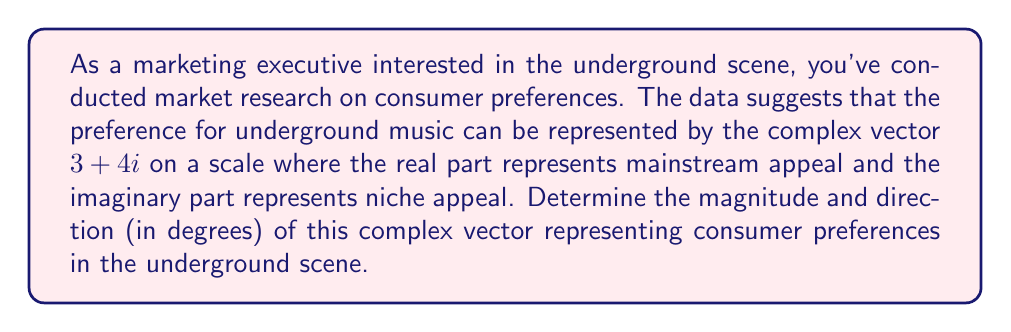Show me your answer to this math problem. To solve this problem, we need to convert the complex vector from rectangular form $(a + bi)$ to polar form $(r \angle \theta)$.

1. Calculate the magnitude (r):
   The magnitude is given by the formula: $r = \sqrt{a^2 + b^2}$
   Where $a = 3$ and $b = 4$
   
   $$r = \sqrt{3^2 + 4^2} = \sqrt{9 + 16} = \sqrt{25} = 5$$

2. Calculate the direction (θ):
   The direction is given by the formula: $\theta = \tan^{-1}(\frac{b}{a})$
   
   $$\theta = \tan^{-1}(\frac{4}{3})$$
   
   Using a calculator or computer:
   $$\theta \approx 0.9272952180 \text{ radians}$$

3. Convert radians to degrees:
   $$\theta \text{ in degrees} = 0.9272952180 \times \frac{180°}{\pi} \approx 53.13010235°$$

Therefore, the complex vector $3 + 4i$ in polar form is approximately $5 \angle 53.13010235°$.

Interpretation:
- The magnitude of 5 indicates the overall strength of consumer preference for the underground scene.
- The angle of approximately 53.13° suggests a balance between mainstream and niche appeal, with a slight lean towards niche appeal.
Answer: Magnitude: 5
Direction: 53.13° (rounded to two decimal places) 